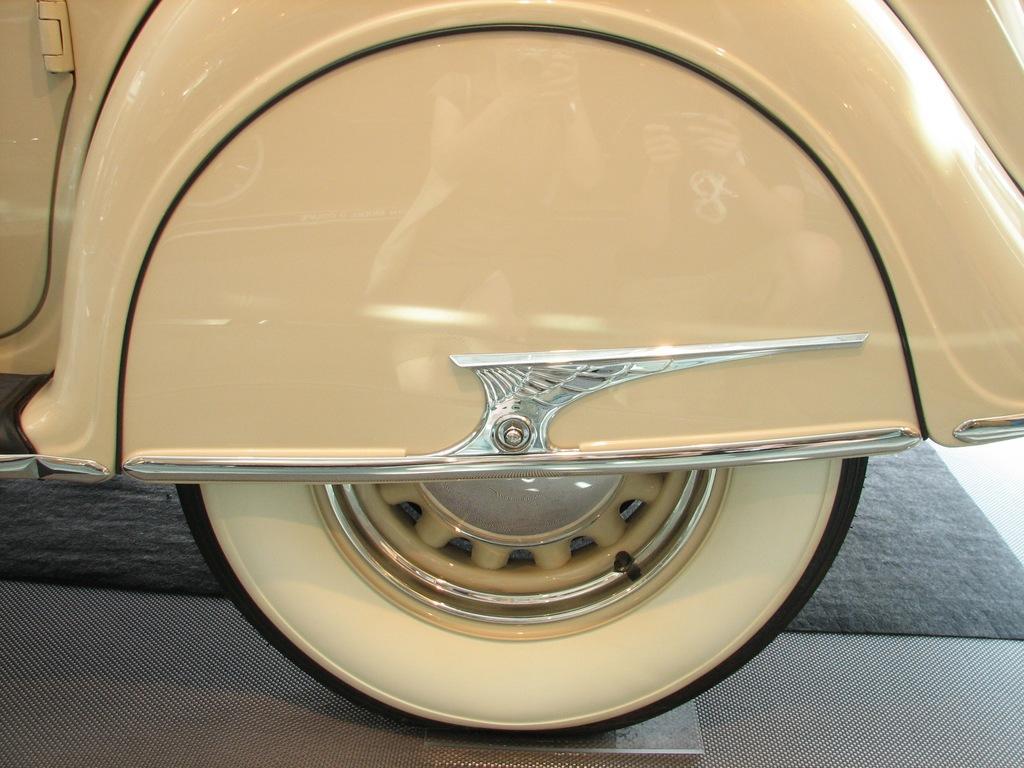Please provide a concise description of this image. In this image I can see it is the Tyre of a vehicle, the body of this vehicle is in cream color. 